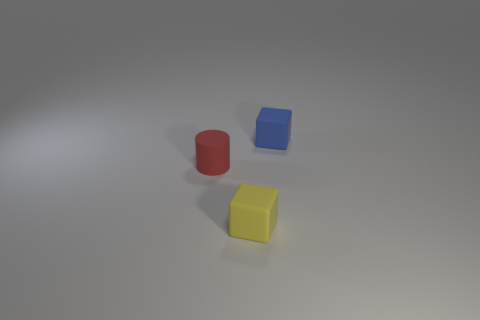How many yellow rubber objects are on the left side of the tiny rubber thing that is to the right of the tiny yellow block?
Provide a succinct answer. 1. Is there a purple matte object?
Offer a very short reply. No. How many other things are the same color as the small cylinder?
Your response must be concise. 0. Is the number of tiny red rubber objects less than the number of rubber cubes?
Give a very brief answer. Yes. What is the shape of the small yellow rubber thing in front of the matte cube behind the small red thing?
Keep it short and to the point. Cube. Are there any yellow things on the right side of the small red thing?
Your answer should be very brief. Yes. There is a matte block that is the same size as the yellow thing; what is its color?
Make the answer very short. Blue. What number of tiny blue cubes have the same material as the tiny cylinder?
Offer a terse response. 1. What number of other objects are there of the same size as the blue matte block?
Your answer should be very brief. 2. Is there another cube of the same size as the yellow block?
Keep it short and to the point. Yes. 